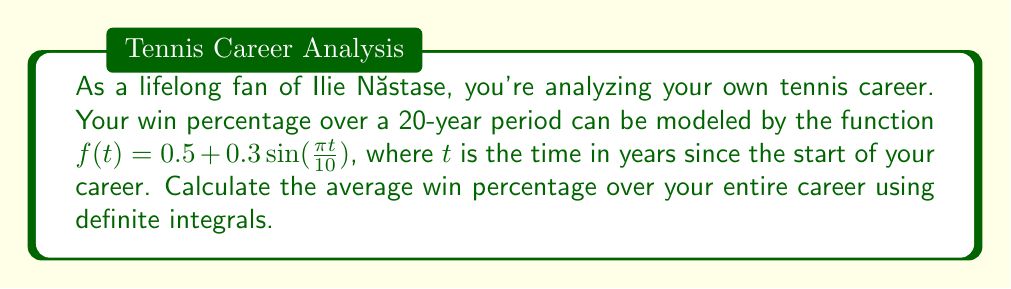Provide a solution to this math problem. To find the average win percentage, we need to calculate the area under the curve of $f(t)$ from $t=0$ to $t=20$ and then divide by the total time period.

1) Set up the definite integral:
   $$\frac{1}{20}\int_0^{20} (0.5 + 0.3\sin(\frac{\pi t}{10})) dt$$

2) Split the integral:
   $$\frac{1}{20}[\int_0^{20} 0.5 dt + \int_0^{20} 0.3\sin(\frac{\pi t}{10}) dt]$$

3) Evaluate the first part:
   $$\frac{1}{20}[0.5t]_0^{20} = \frac{1}{20}[10] = 0.5$$

4) For the second part, use u-substitution:
   Let $u = \frac{\pi t}{10}$, then $du = \frac{\pi}{10}dt$ and $dt = \frac{10}{\pi}du$
   New limits: when $t=0$, $u=0$; when $t=20$, $u=2\pi$

   $$\frac{1}{20}[\frac{3}{\pi}\int_0^{2\pi} \sin(u) du]$$

5) Evaluate:
   $$\frac{1}{20}[\frac{3}{\pi}[-\cos(u)]_0^{2\pi}] = \frac{1}{20}[\frac{3}{\pi}[-\cos(2\pi) + \cos(0)]] = \frac{1}{20}[\frac{3}{\pi}[0]] = 0$$

6) Sum the results from steps 3 and 5:
   $$0.5 + 0 = 0.5$$

Therefore, the average win percentage over your 20-year career is 0.5 or 50%.
Answer: 0.5 